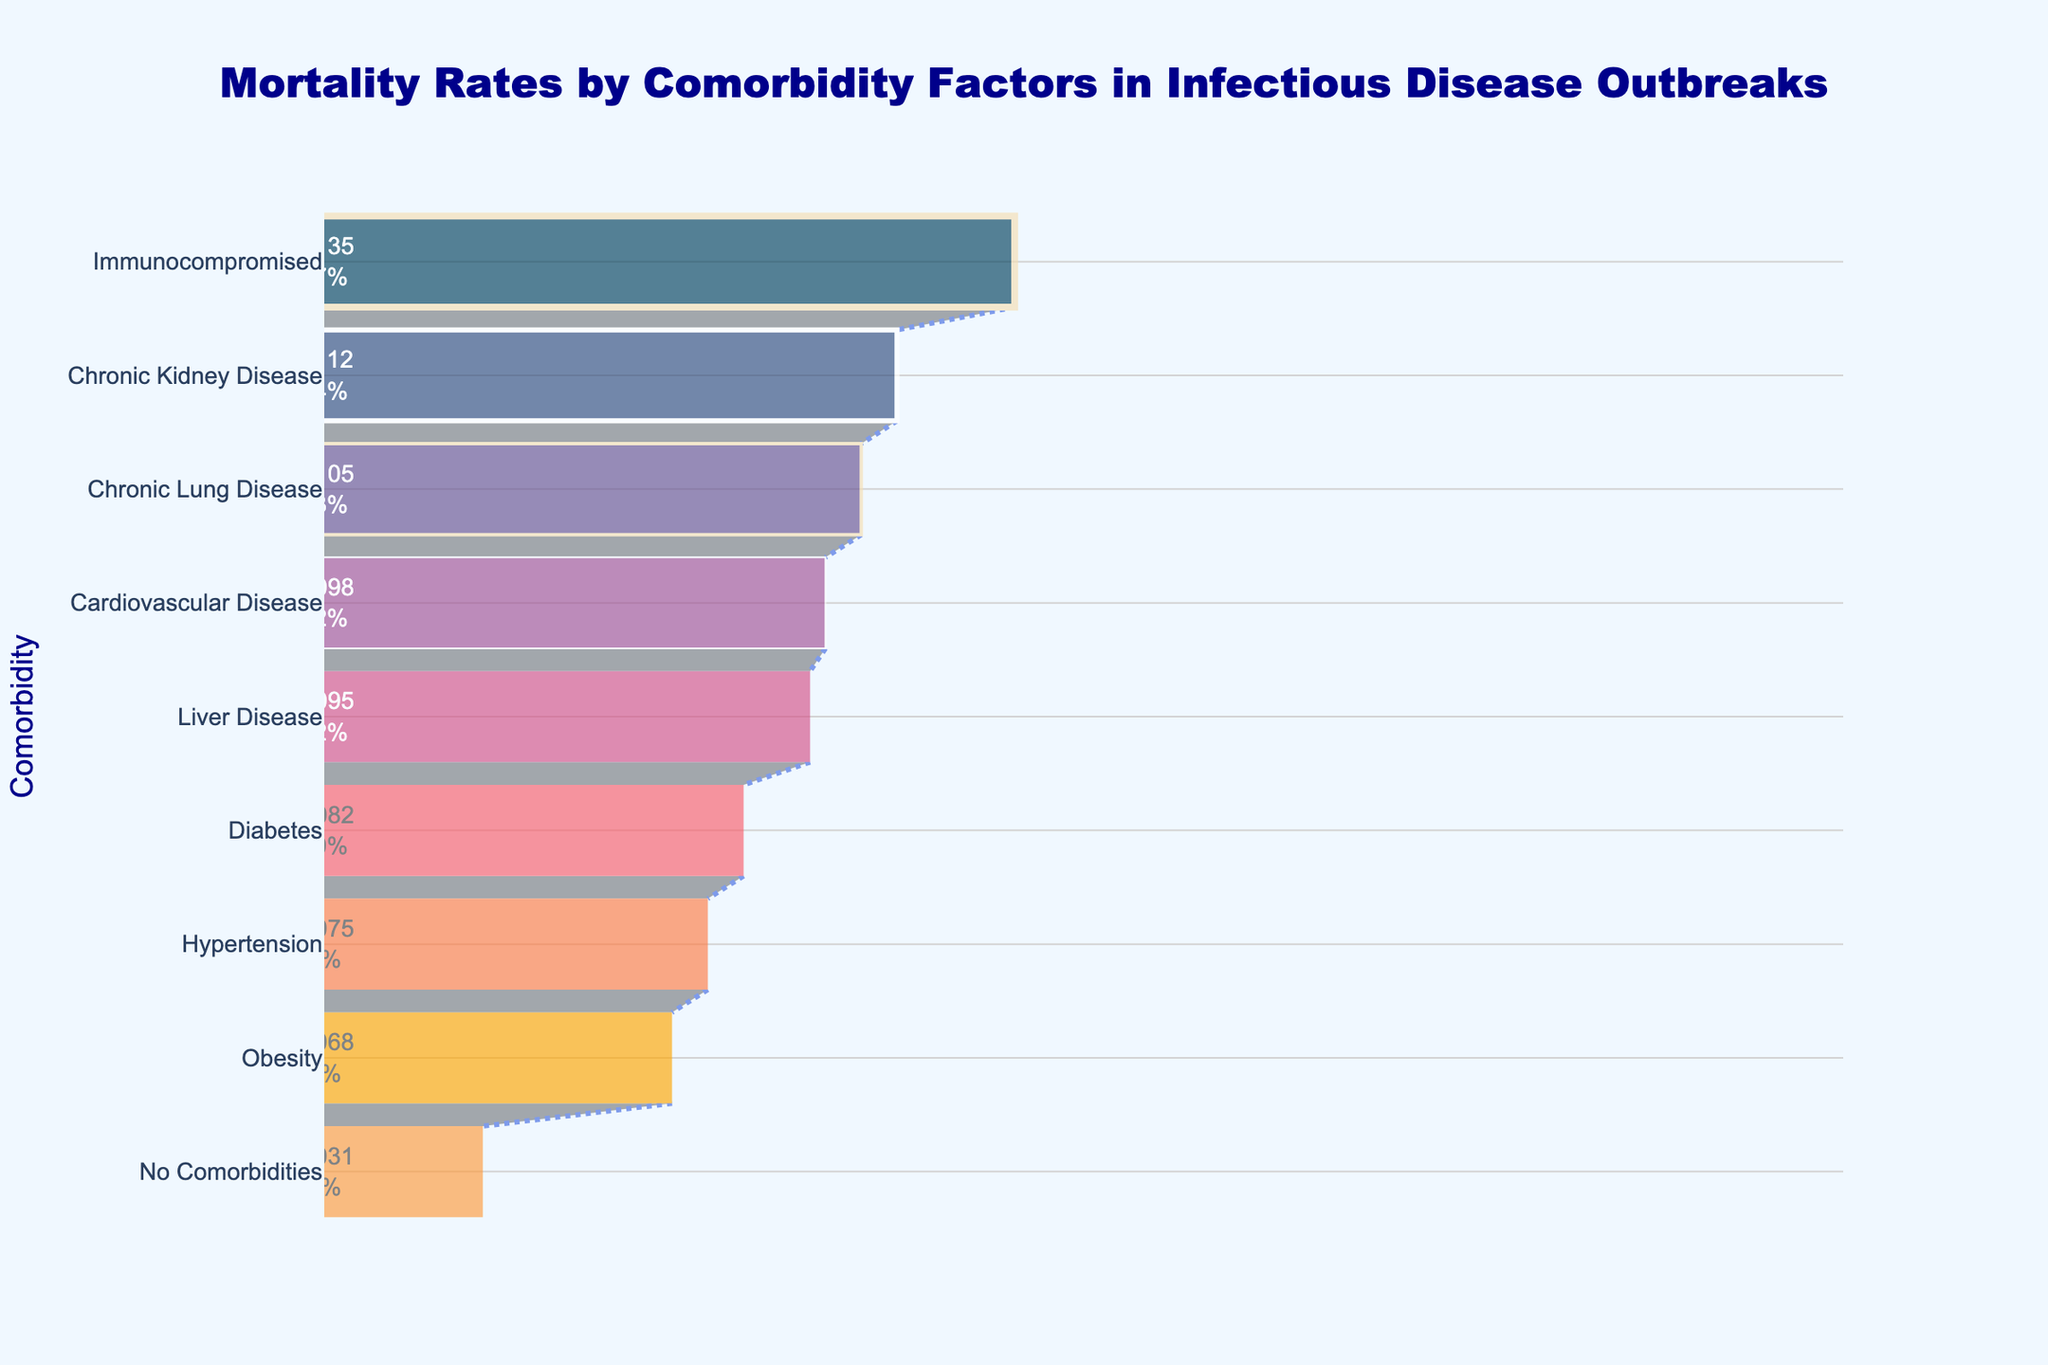What is the title of the figure? The title of the figure is prominently displayed at the top and clearly reads "Mortality Rates by Comorbidity Factors in Infectious Disease Outbreaks".
Answer: Mortality Rates by Comorbidity Factors in Infectious Disease Outbreaks Which comorbidity has the highest mortality rate? To find the comorbidity with the highest mortality rate, look at the top of the funnel where the widest segment is located. The widest segment represents the highest mortality rate, and the associated comorbidity can be identified at the top of the funnel chart.
Answer: Immunocompromised How does the mortality rate of Hypertension compare to Chronic Kidney Disease? Look for both the Hypertension and Chronic Kidney Disease segments within the funnel chart. Note the respective positions and percentages. Hypertension is lower down the funnel than Chronic Kidney Disease, meaning its mortality rate is lower.
Answer: Chronic Kidney Disease has a higher mortality rate than Hypertension What is the mortality rate for patients with Cardiovascular Disease? Identify the segment labelled Cardiovascular Disease on the funnel chart and note the mortality rate percentage indicated within the segment.
Answer: 9.8% Which comorbidity has an approximately 6.8% mortality rate? Find the segment in the funnel chart that displays 6.8%. Then, look at the label on the y-axis associated with this segment.
Answer: Obesity What is the average mortality rate among Chronic Lung Disease, Cardiovascular Disease, and Chronic Kidney Disease? Look at the mortality rates for Chronic Lung Disease (10.5%), Cardiovascular Disease (9.8%), and Chronic Kidney Disease (11.2%). Sum these values and divide by the number of comorbidities: (10.5% + 9.8% + 11.2%) / 3 = 10.5%
Answer: 10.5% What is the difference in mortality rate between Liver Disease and Diabetes? Look at the mortality rates for both Liver Disease (9.5%) and Diabetes (8.2%). Subtract the lower rate from the higher rate: 9.5% - 8.2% = 1.3%
Answer: 1.3% How many comorbidities have a higher mortality rate than Hypertension? Identify the mortality rate for Hypertension (7.5%) and count the number of segments higher up the funnel, meaning they have a higher mortality rate than Hypertension.
Answer: 4 Which comorbidity is closest in mortality rate to No Comorbidities? Find the mortality rate for No Comorbidities (3.1%) and look for the comorbidity with a rate closest to this value. Obesity has a rate (6.8%) much higher than the others. However, as no comorbidities have a value close to 3.1%, a closer comorbidity is Obesity (6.8%).
Answer: Obesity What is the total number of comorbidities displayed in the funnel chart? Count the number of distinct comorbidities listed on the y-axis of the funnel chart.
Answer: 9 